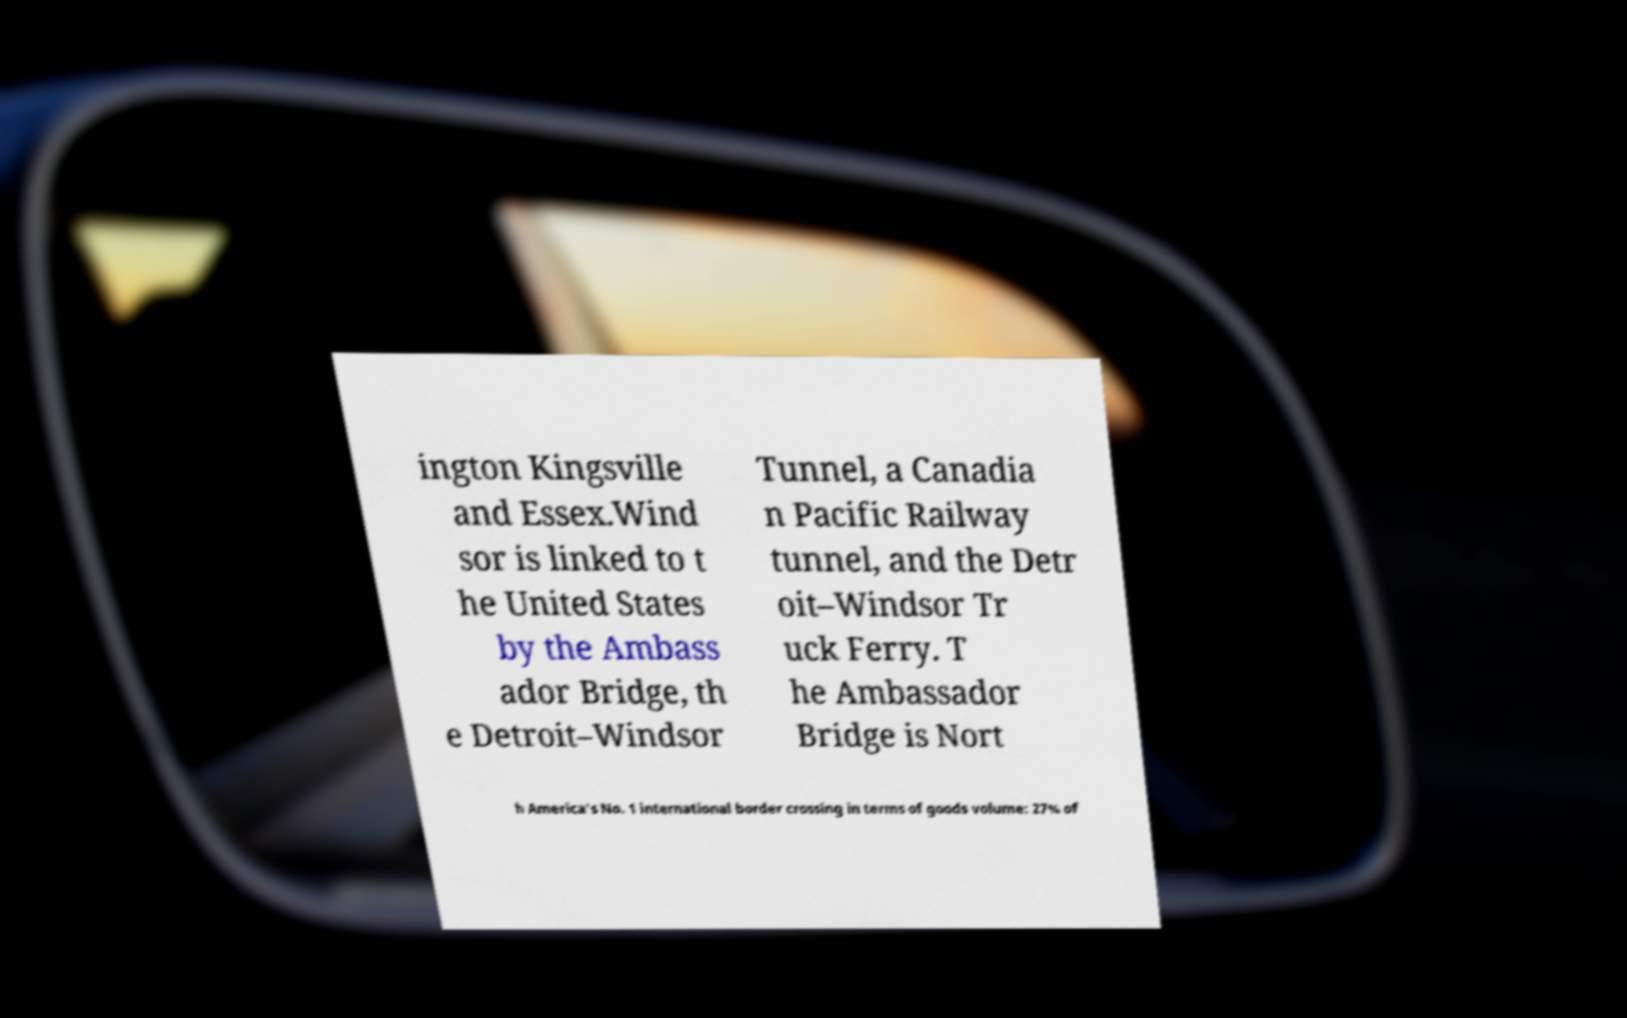Could you extract and type out the text from this image? ington Kingsville and Essex.Wind sor is linked to t he United States by the Ambass ador Bridge, th e Detroit–Windsor Tunnel, a Canadia n Pacific Railway tunnel, and the Detr oit–Windsor Tr uck Ferry. T he Ambassador Bridge is Nort h America's No. 1 international border crossing in terms of goods volume: 27% of 